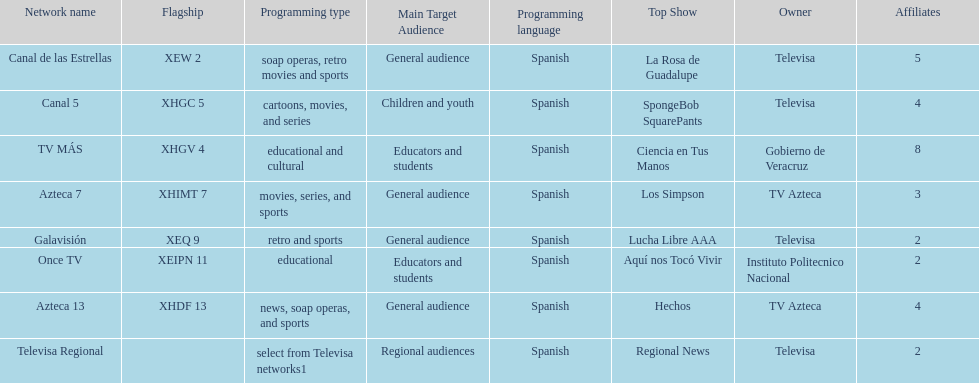Which is the only station with 8 affiliates? TV MÁS. 